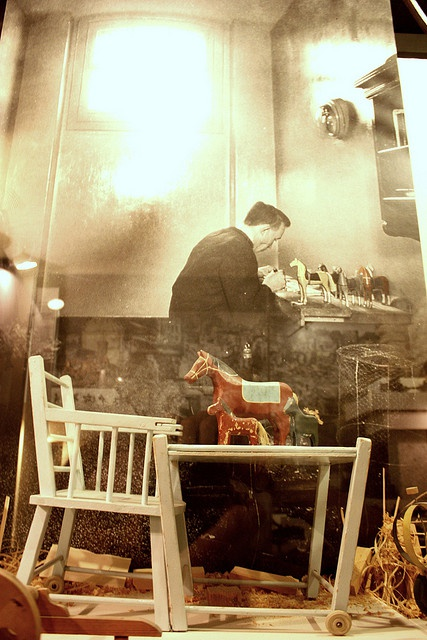Describe the objects in this image and their specific colors. I can see chair in black, khaki, maroon, and brown tones, people in black, maroon, olive, tan, and khaki tones, horse in black, brown, maroon, and khaki tones, horse in black, brown, tan, and maroon tones, and horse in black, khaki, tan, lightyellow, and olive tones in this image. 